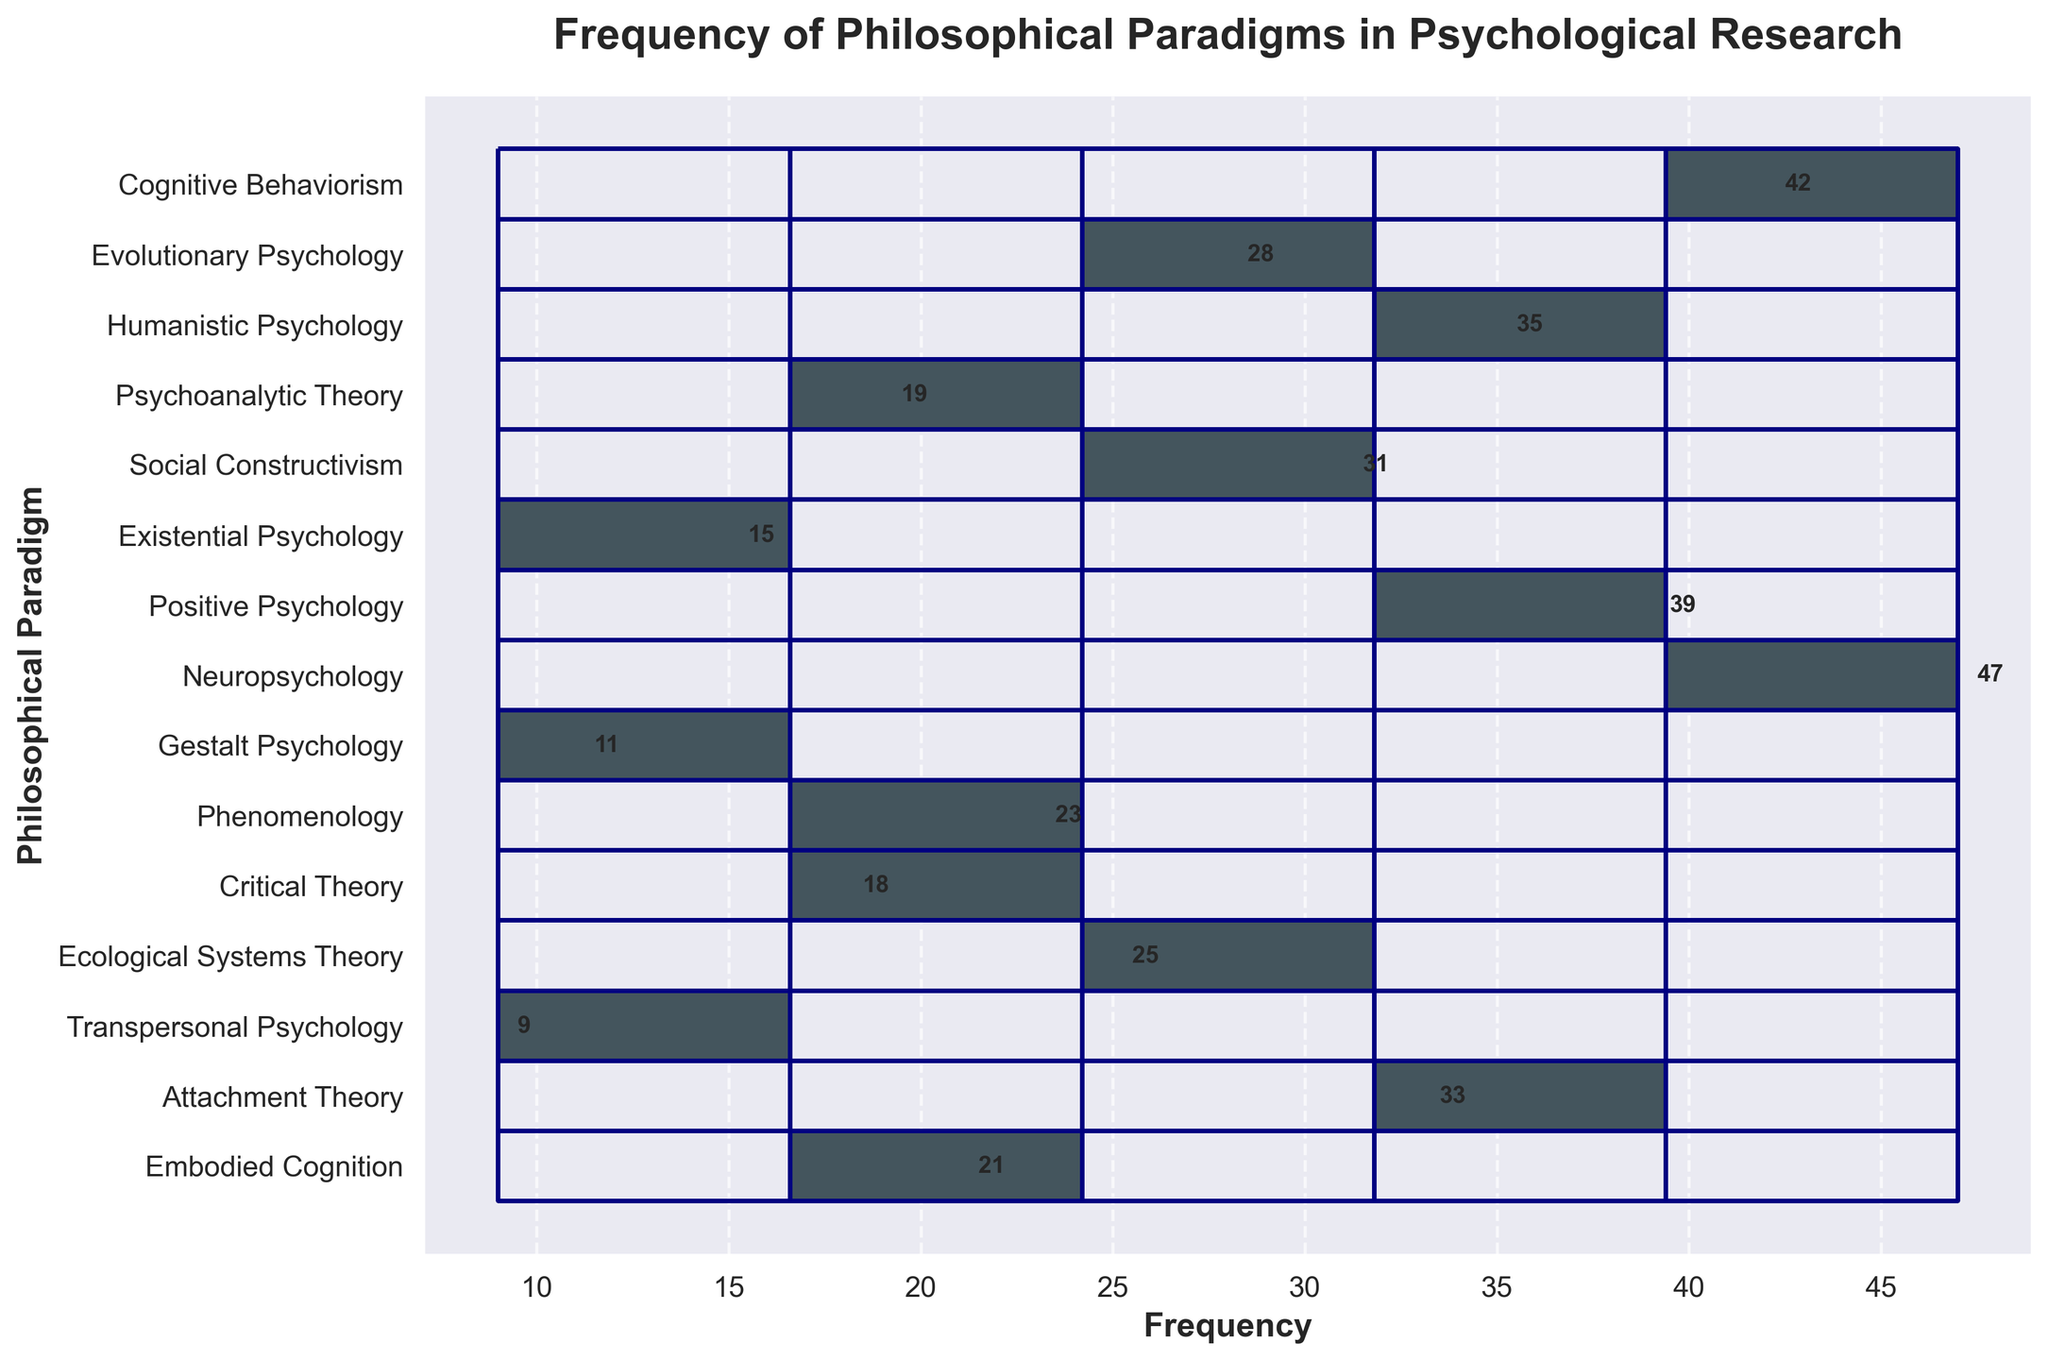Which philosophical paradigm has the highest frequency? Identify the bars in the histogram. The tallest bar corresponds to "Neuropsychology."
Answer: Neuropsychology What is the sum of frequencies for Cognitive Behaviorism, Evolutionary Psychology, and Humanistic Psychology? Add the frequencies 42 (Cognitive Behaviorism) + 28 (Evolutionary Psychology) + 35 (Humanistic Psychology). The sum is 105.
Answer: 105 Which paradigm has the second lowest frequency? Arrange the paradigms by their frequencies in ascending order. The second lowest is "Transpersonal Psychology" with 9.
Answer: Transpersonal Psychology By how much does the frequency of Positive Psychology exceed that of Psychoanalytic Theory? Subtract the frequency of Psychoanalytic Theory from Positive Psychology (39 - 19). The difference is 20.
Answer: 20 What is the median frequency of the paradigms listed? Organize the paradigms' frequencies in ascending order and find the middle value. The ordered frequencies are 9, 11, 15, 18, 19, 21, 23, 25, 28, 31, 33, 35, 39, 42, 47, so the median (middle value of the ordered list) is 25.
Answer: 25 Is the KDE curve higher for frequencies around 10 or 20? Observe the height of the KDE curve at frequencies around 10 and 20. It is higher around 20.
Answer: 20 Which paradigm falls between Embodied Cognition and Critical Theory in terms of frequency? Check the figure for paradigms listed closely to the 21 (Embodied Cognition) and 18 (Critical Theory). Phenomenology (23) is between them.
Answer: Phenomenology What is the average frequency of all the paradigms combined? Sum all frequencies and divide by the number of paradigms (42+28+35+19+31+15+39+47+11+23+18+25+9+33+21 = 396, 396 / 15 = 26.4).
Answer: 26.4 